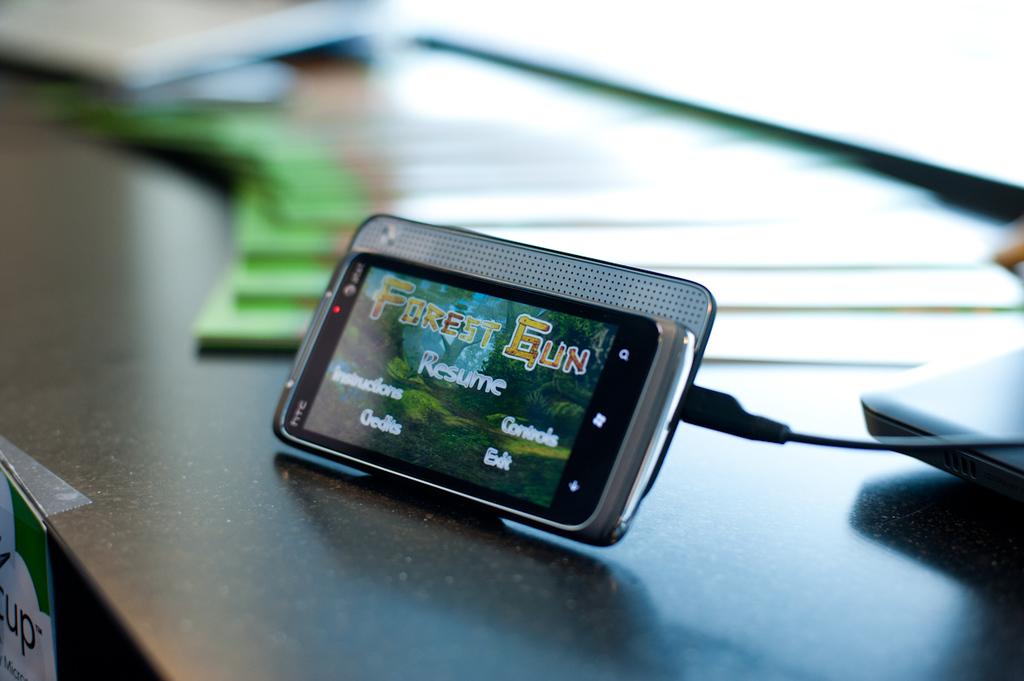What kind of phone is this?
Ensure brevity in your answer.  Htc. What game is on the screen?
Keep it short and to the point. Forest gun. 